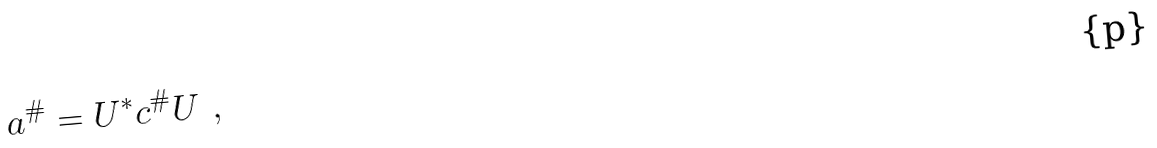<formula> <loc_0><loc_0><loc_500><loc_500>a ^ { \# } = U ^ { * } c ^ { \# } U \ ,</formula> 